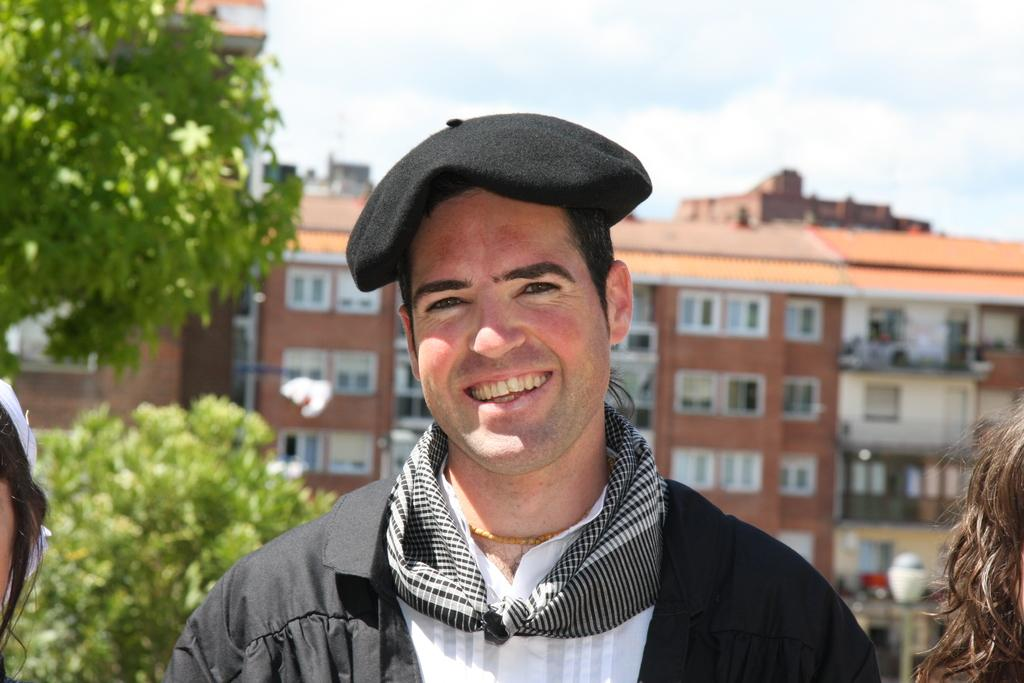How many persons can be seen in the image? There are persons in the image, but the exact number is not specified. What can be seen in the background of the image? There are trees, a building, a light pole, and the sky visible in the background of the image. Can you see a bear climbing the light pole in the image? No, there is no bear present in the image. 